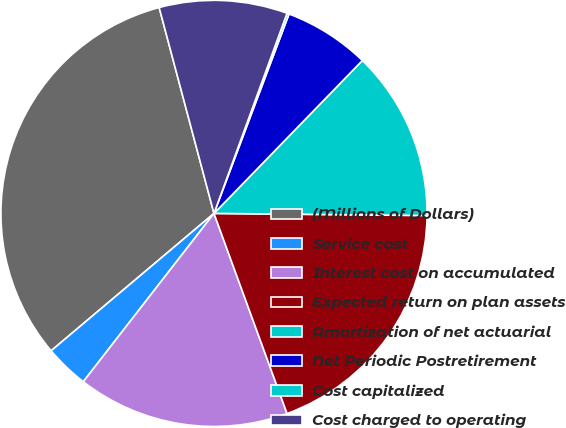Convert chart to OTSL. <chart><loc_0><loc_0><loc_500><loc_500><pie_chart><fcel>(Millions of Dollars)<fcel>Service cost<fcel>Interest cost on accumulated<fcel>Expected return on plan assets<fcel>Amortization of net actuarial<fcel>Net Periodic Postretirement<fcel>Cost capitalized<fcel>Cost charged to operating<nl><fcel>32.01%<fcel>3.34%<fcel>16.08%<fcel>19.27%<fcel>12.9%<fcel>6.53%<fcel>0.16%<fcel>9.71%<nl></chart> 